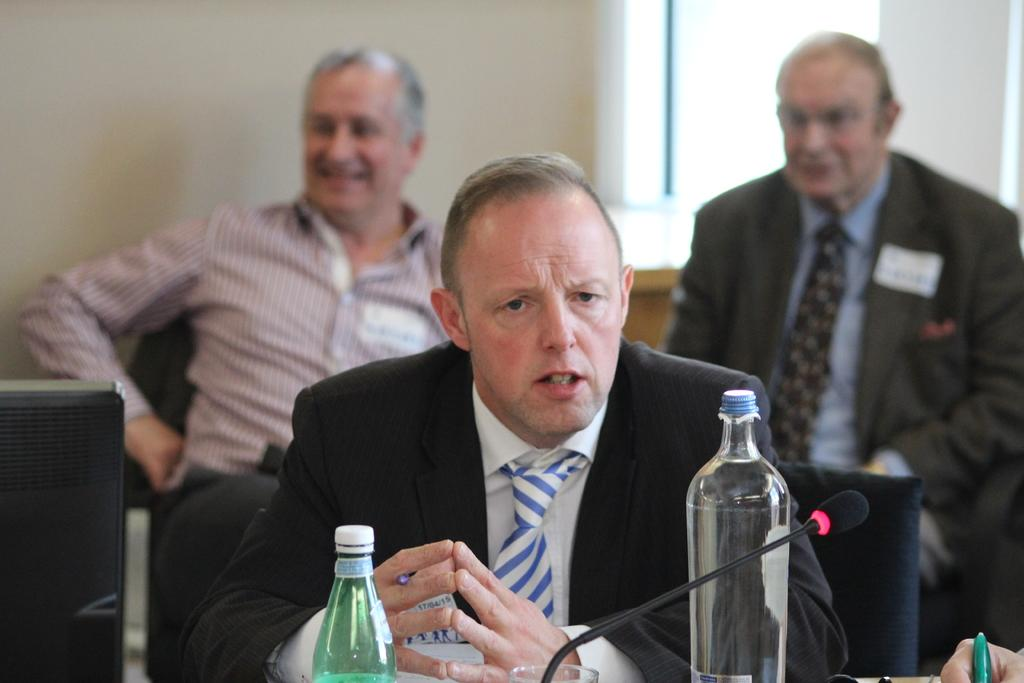How many people are sitting in the image? There are three men sitting in the image. What objects can be seen near the men? There are bottles visible in the image. What device is present in the image that is used for amplifying sound? There is a microphone (mic) in the image. Whose hand is visible in the image? A hand of a person is visible in the image. What type of calendar is hanging on the wall in the image? There is no calendar present in the image. How many feet can be seen in the image? There is no reference to feet in the image, as it features three men sitting and a hand of a person visible. 